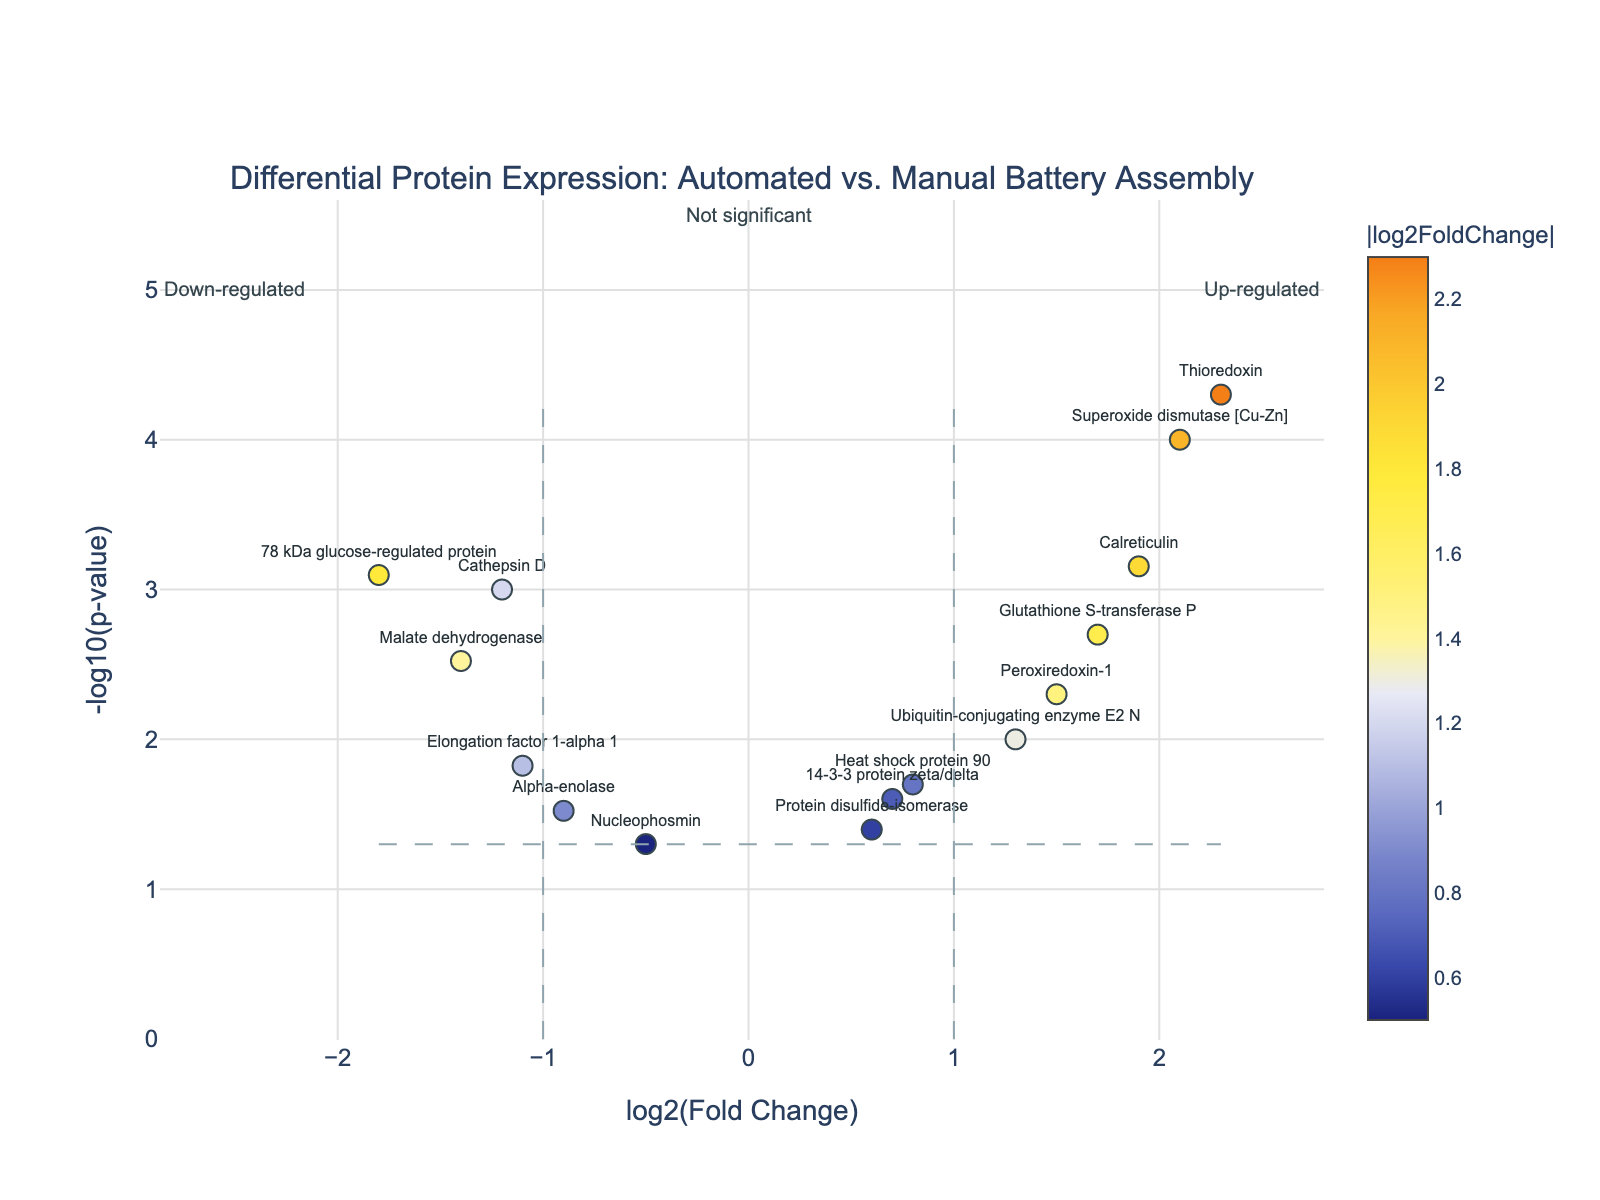What is the title of the plot? The title is located at the top of the volcano plot and provides a summary of what the plot represents. Reading the title at the top of the figure: "Differential Protein Expression: Automated vs. Manual Battery Assembly"
Answer: Differential Protein Expression: Automated vs. Manual Battery Assembly What does the x-axis represent in the plot? The x-axis is labeled at the bottom and indicates the measure being shown. The label reads "log2(Fold Change)".
Answer: log2(Fold Change) How many proteins are down-regulated with a p-value less than 0.05? Down-regulated proteins have negative log2(Fold Change) values, and a p-value less than 0.05 corresponds to values above the horizontal line at -log10(p-value) of 1.3. Identify the data points on the left side of the vertical lines and above the horizontal line.
Answer: 6 Which protein has the highest log2(Fold Change)? The highest log2(Fold Change) is identified by finding the data point furthest to the right on the x-axis. The hover text confirms the protein identity.
Answer: Thioredoxin What is the interpretation of a point that is above 1.3 on the y-axis and at -2 on the x-axis? Points above 1.3 on the y-axis indicate p-values less than 0.05 (significant), and points at -2 on the x-axis indicate a log2(Fold Change) of -2 (down-regulated). This combination means the protein is significantly down-regulated.
Answer: Significantly down-regulated How many proteins are significantly up-regulated? Significantly up-regulated proteins have positive log2(Fold Change) values and are above the horizontal line at -log10(p-value) of 1.3. Count the data points on the right side of the vertical lines and above the horizontal line.
Answer: 6 Which protein has a log2(Fold Change) of approximately 1.7 and a significant p-value? Look for the data point positioned near 1.7 on the x-axis and above 1.3 on the y-axis. Reading the hover text associated with this data point will confirm the protein identity.
Answer: Glutathione S-transferase P Compare the log2(Fold Change) of Superoxide dismutase [Cu-Zn] and Elongation factor 1-alpha 1. Which one is higher? Identify the log2(Fold Change) values for Superoxide dismutase [Cu-Zn] (2.1) and Elongation factor 1-alpha 1 (-1.1). Compare the values directly.
Answer: Superoxide dismutase [Cu-Zn] What does the horizontal dashed line at 1.3 on the y-axis represent? The horizontal dashed line's value can be estimated by checking the y-axis annotation and notes on the plot. This line commonly represents a p-value threshold of 0.05, i.e., -log10(0.05).
Answer: p-value threshold of 0.05 Which proteins are neither significantly up-regulated nor down-regulated? Proteins not significantly regulated are below the horizontal line at -log10(p-value) of 1.3. They lie between the vertical lines at log2(Fold Change) of -1 and 1. Identify the data points in this region.
Answer: Nucleophosmin, 14-3-3 protein zeta/delta, Protein disulfide-isomerase, Heat shock protein 90 